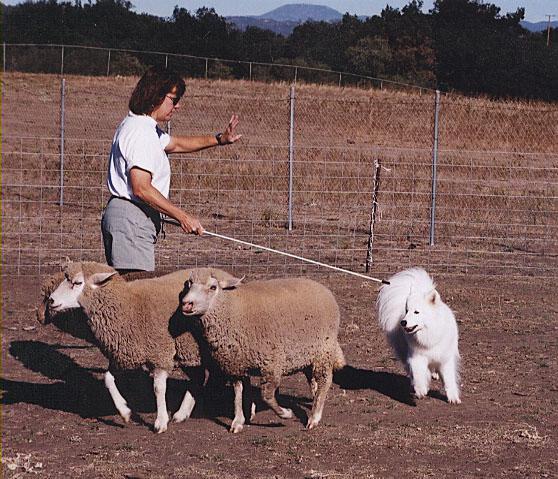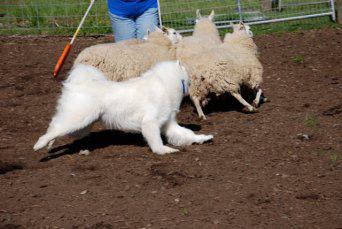The first image is the image on the left, the second image is the image on the right. Given the left and right images, does the statement "An image shows a white dog with a flock of ducks." hold true? Answer yes or no. No. The first image is the image on the left, the second image is the image on the right. Examine the images to the left and right. Is the description "there are exactly three sheep in one of the images" accurate? Answer yes or no. Yes. 